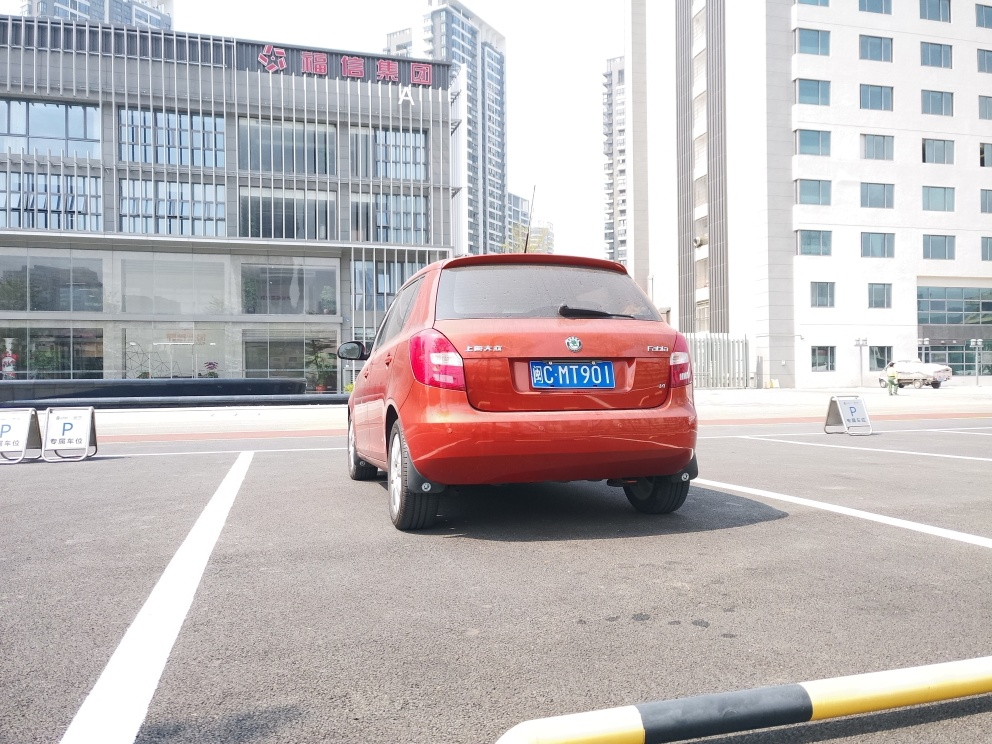What can you tell me about the type of car in the image? The vehicle in the image is a red hatchback, which seems to be in good condition with a well-maintained exterior. It is a modern economy car, likely designed for city driving given its compact size that is suitable for urban environments with tight parking spaces. The hatchback design suggests that it offers a functional balance of passenger space and cargo capacity, making it a practical choice for everyday use. The brand emblem is visible, but I'm unable to specify the model as it would involve identifying or endorsing specific brands. 